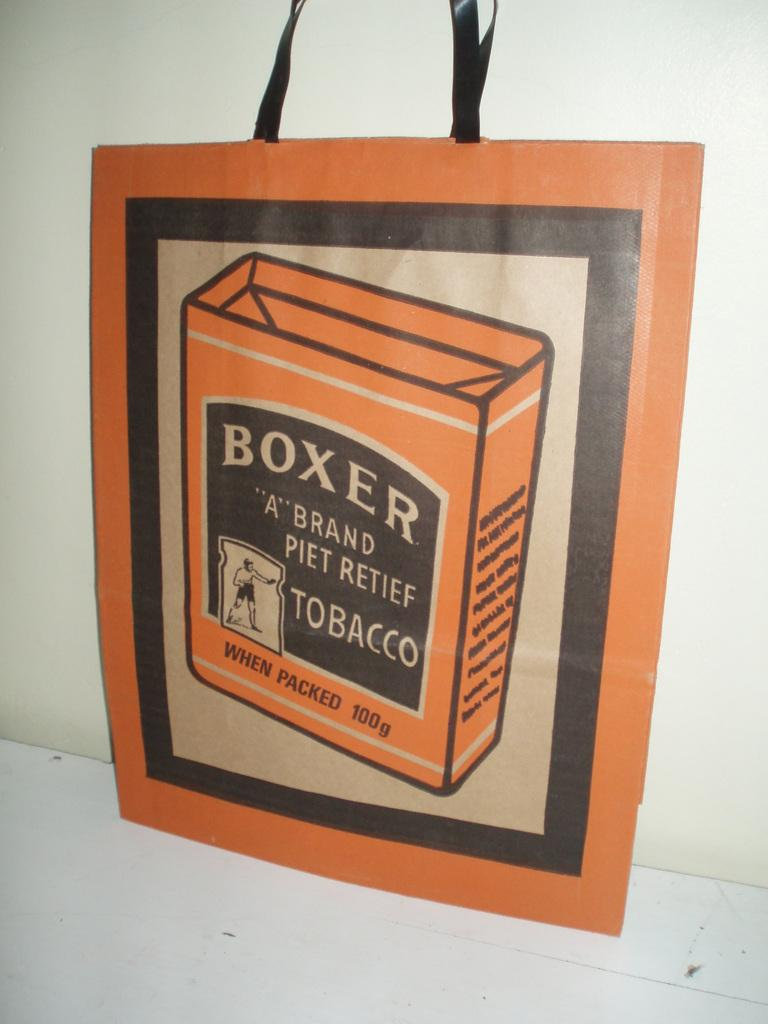What object can be seen in the image? There is a bag in the image. What is visible in the background of the image? There is a wall in the background of the image. How many feet are visible in the image? There are no feet visible in the image. What type of destruction can be seen in the image? There is no destruction present in the image; it features a bag and a wall. 